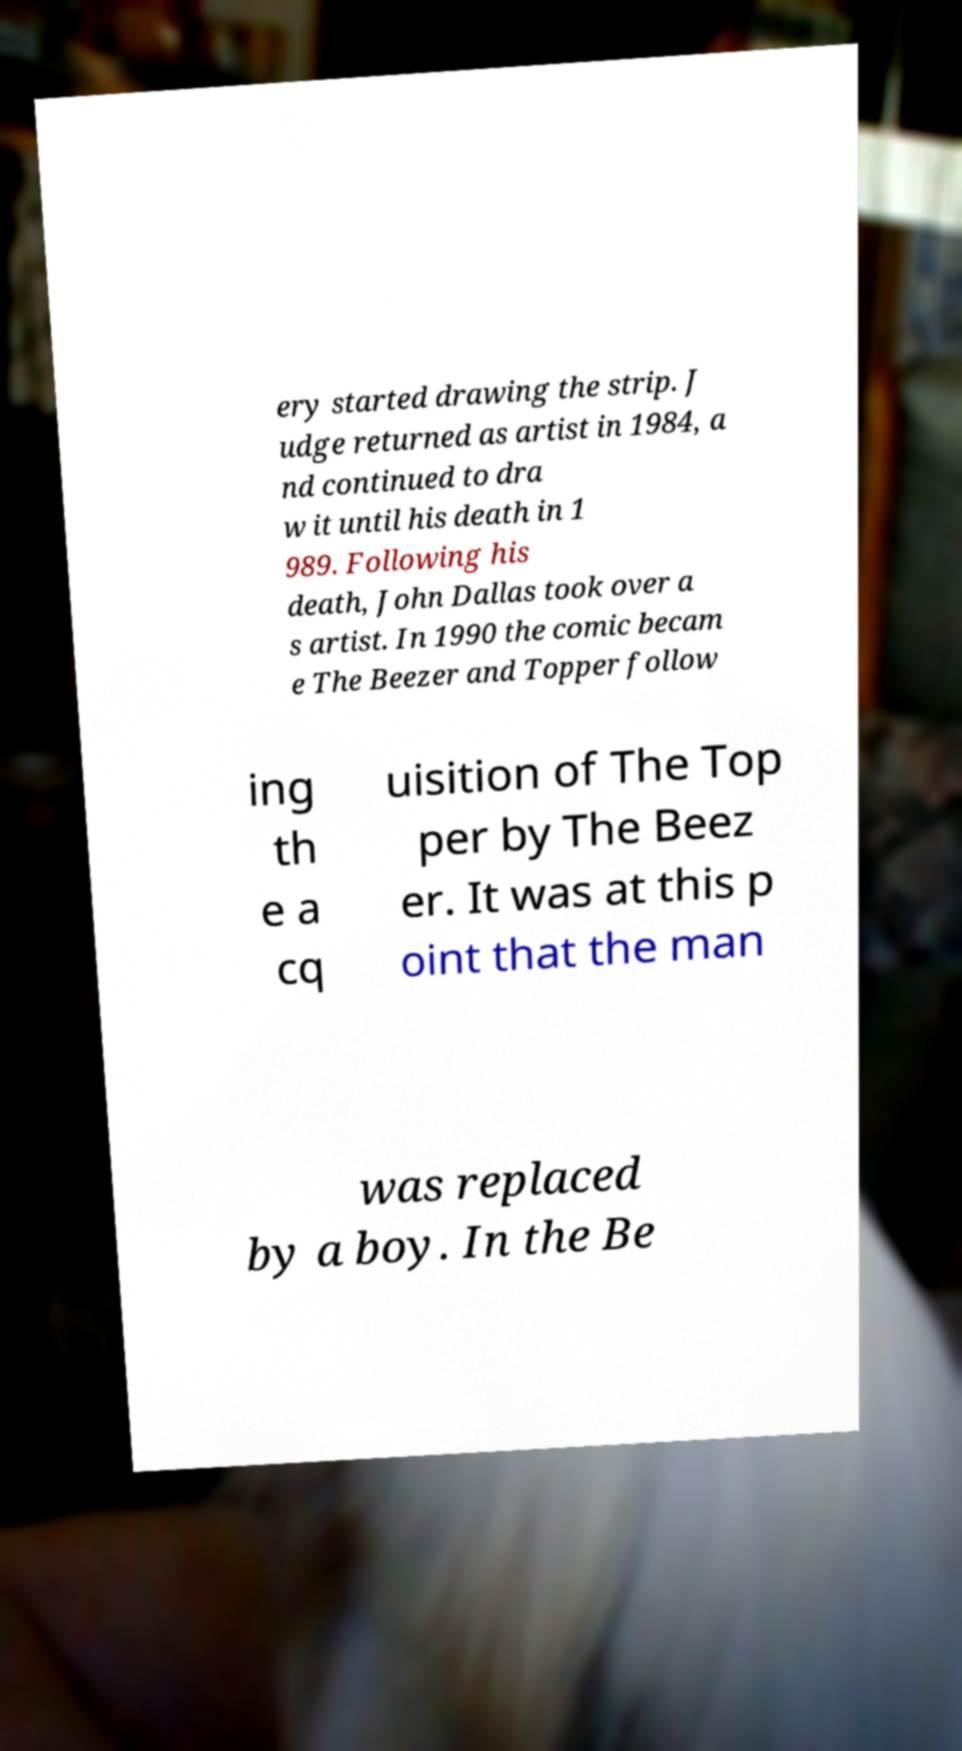Can you read and provide the text displayed in the image?This photo seems to have some interesting text. Can you extract and type it out for me? ery started drawing the strip. J udge returned as artist in 1984, a nd continued to dra w it until his death in 1 989. Following his death, John Dallas took over a s artist. In 1990 the comic becam e The Beezer and Topper follow ing th e a cq uisition of The Top per by The Beez er. It was at this p oint that the man was replaced by a boy. In the Be 